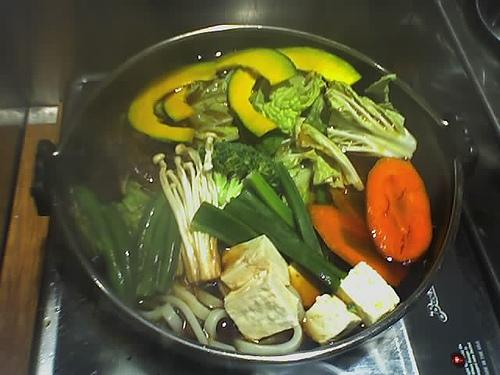What are the white blocks in the soup called? Please explain your reasoning. tofu. The food looks processed and is used in asian cooking. 